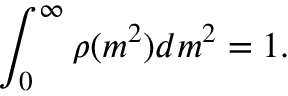Convert formula to latex. <formula><loc_0><loc_0><loc_500><loc_500>\int _ { 0 } ^ { \infty } \rho ( m ^ { 2 } ) d m ^ { 2 } = 1 .</formula> 